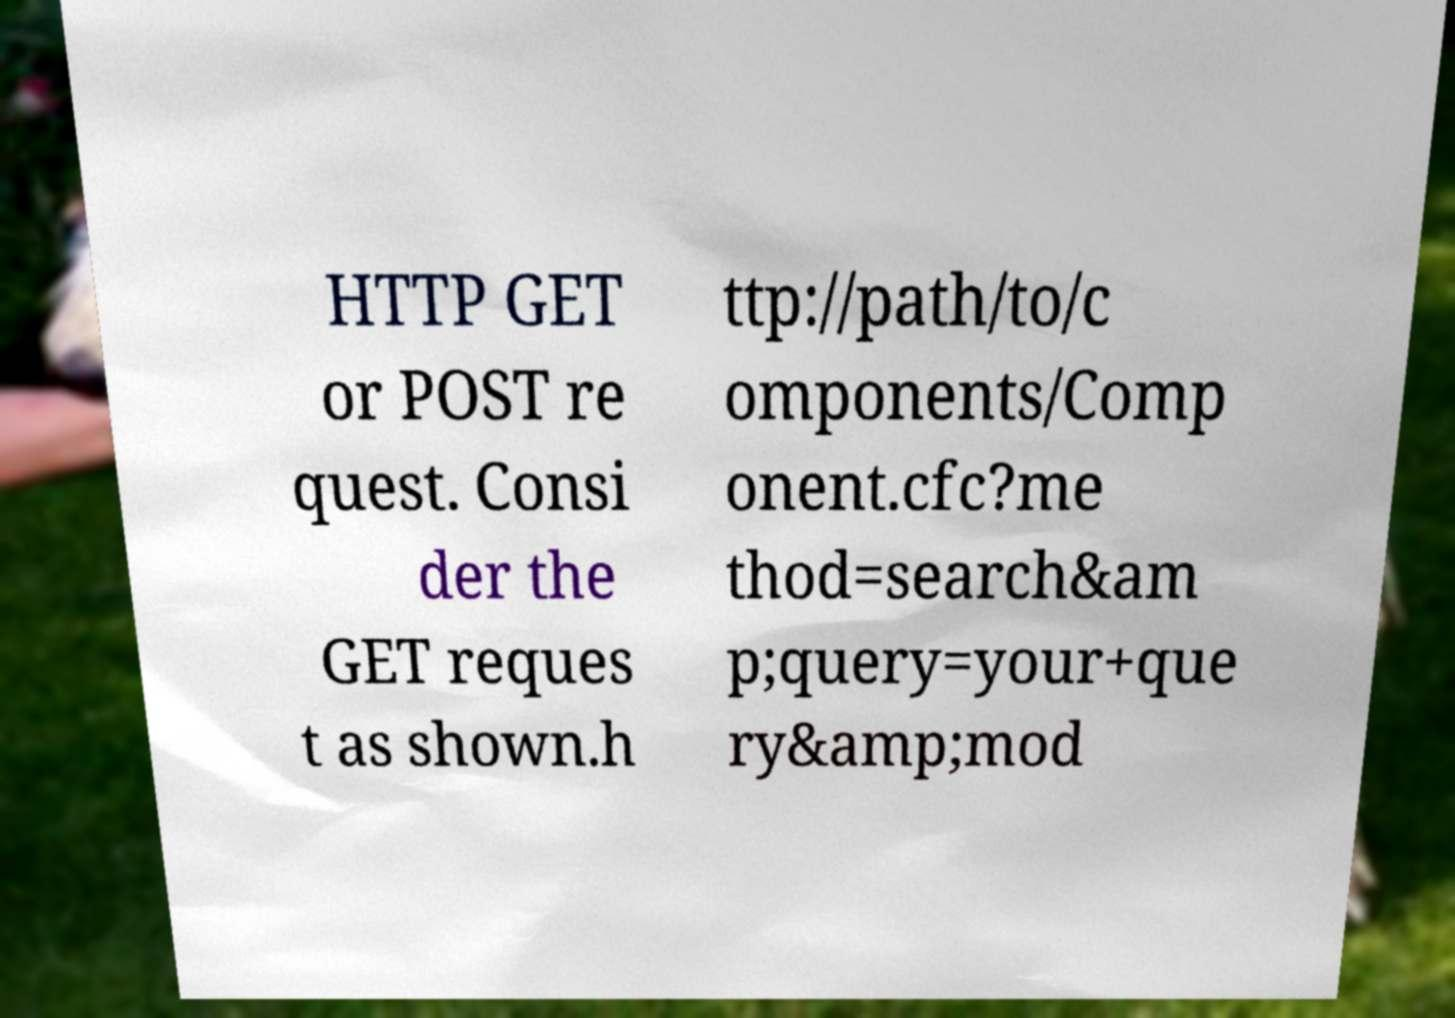What messages or text are displayed in this image? I need them in a readable, typed format. HTTP GET or POST re quest. Consi der the GET reques t as shown.h ttp://path/to/c omponents/Comp onent.cfc?me thod=search&am p;query=your+que ry&amp;mod 